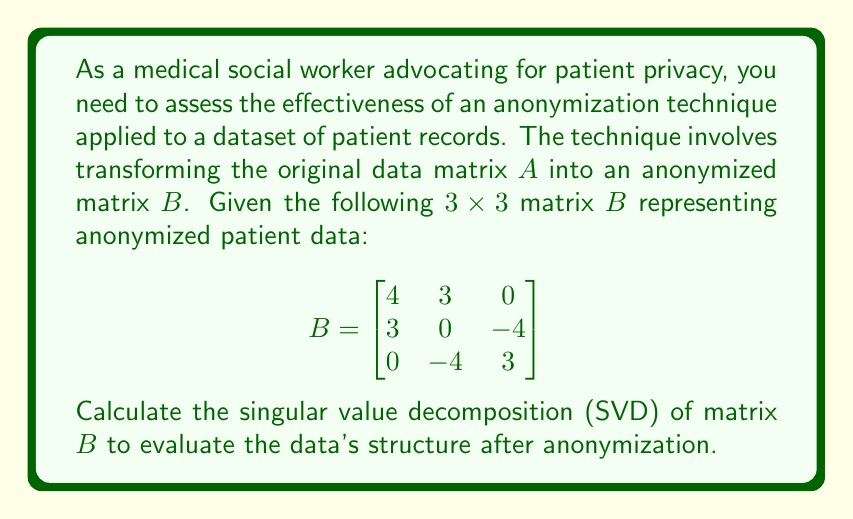Provide a solution to this math problem. To calculate the singular value decomposition (SVD) of matrix $B$, we need to find matrices $U$, $\Sigma$, and $V^T$ such that $B = U\Sigma V^T$. Here's the step-by-step process:

1) First, calculate $B^TB$ and $BB^T$:

   $B^TB = \begin{bmatrix}
   4 & 3 & 0 \\
   3 & 0 & -4 \\
   0 & -4 & 3
   \end{bmatrix} \begin{bmatrix}
   4 & 3 & 0 \\
   3 & 0 & -4 \\
   0 & -4 & 3
   \end{bmatrix} = \begin{bmatrix}
   25 & 12 & -12 \\
   12 & 25 & 0 \\
   -12 & 0 & 25
   \end{bmatrix}$

   $BB^T = \begin{bmatrix}
   25 & 12 & -12 \\
   12 & 25 & 0 \\
   -12 & 0 & 25
   \end{bmatrix}$

2) Find the eigenvalues of $B^TB$ (or $BB^T$) by solving $\det(B^TB - \lambda I) = 0$:

   $\det\begin{pmatrix}
   25-\lambda & 12 & -12 \\
   12 & 25-\lambda & 0 \\
   -12 & 0 & 25-\lambda
   \end{pmatrix} = 0$

   Solving this equation gives us: $\lambda_1 = 49$, $\lambda_2 = \lambda_3 = 13$

3) The singular values are the square roots of these eigenvalues:
   $\sigma_1 = 7$, $\sigma_2 = \sigma_3 = \sqrt{13}$

4) To find $V$, solve $(B^TB - \lambda_i I)v_i = 0$ for each eigenvalue:

   For $\lambda_1 = 49$:
   $\begin{bmatrix}
   -24 & 12 & -12 \\
   12 & -24 & 0 \\
   -12 & 0 & -24
   \end{bmatrix} \begin{bmatrix}
   v_{11} \\ v_{21} \\ v_{31}
   \end{bmatrix} = \begin{bmatrix}
   0 \\ 0 \\ 0
   \end{bmatrix}$

   Solving this gives us: $v_1 = \frac{1}{\sqrt{3}}[1, 1, 1]^T$

   Similarly, for $\lambda_2 = \lambda_3 = 13$, we get:
   $v_2 = \frac{1}{\sqrt{2}}[-1, 0, 1]^T$ and $v_3 = \frac{1}{\sqrt{6}}[-1, 2, -1]^T$

5) To find $U$, we can use the relation $Bv_i = \sigma_i u_i$:

   $u_1 = \frac{1}{\sigma_1}Bv_1 = \frac{1}{7\sqrt{3}}[7, 7, -7]^T = \frac{1}{\sqrt{3}}[1, 1, -1]^T$
   $u_2 = \frac{1}{\sigma_2}Bv_2 = \frac{1}{\sqrt{26}}[-1, 5, 4]^T$
   $u_3 = \frac{1}{\sigma_3}Bv_3 = \frac{1}{\sqrt{26}}[5, 1, 4]^T$

6) Therefore, the SVD of $B$ is:

   $B = U\Sigma V^T = \begin{bmatrix}
   \frac{1}{\sqrt{3}} & -\frac{1}{\sqrt{26}} & \frac{5}{\sqrt{26}} \\
   \frac{1}{\sqrt{3}} & \frac{5}{\sqrt{26}} & \frac{1}{\sqrt{26}} \\
   -\frac{1}{\sqrt{3}} & \frac{4}{\sqrt{26}} & \frac{4}{\sqrt{26}}
   \end{bmatrix} \begin{bmatrix}
   7 & 0 & 0 \\
   0 & \sqrt{13} & 0 \\
   0 & 0 & \sqrt{13}
   \end{bmatrix} \begin{bmatrix}
   \frac{1}{\sqrt{3}} & \frac{1}{\sqrt{3}} & \frac{1}{\sqrt{3}} \\
   -\frac{1}{\sqrt{2}} & 0 & \frac{1}{\sqrt{2}} \\
   -\frac{1}{\sqrt{6}} & \frac{2}{\sqrt{6}} & -\frac{1}{\sqrt{6}}
   \end{bmatrix}$
Answer: $B = U\Sigma V^T$, where:
$U = [\frac{1}{\sqrt{3}}(1,1,-1)^T, \frac{1}{\sqrt{26}}(-1,5,4)^T, \frac{1}{\sqrt{26}}(5,1,4)^T]$
$\Sigma = \text{diag}(7,\sqrt{13},\sqrt{13})$
$V = [\frac{1}{\sqrt{3}}(1,1,1)^T, \frac{1}{\sqrt{2}}(-1,0,1)^T, \frac{1}{\sqrt{6}}(-1,2,-1)^T]$ 